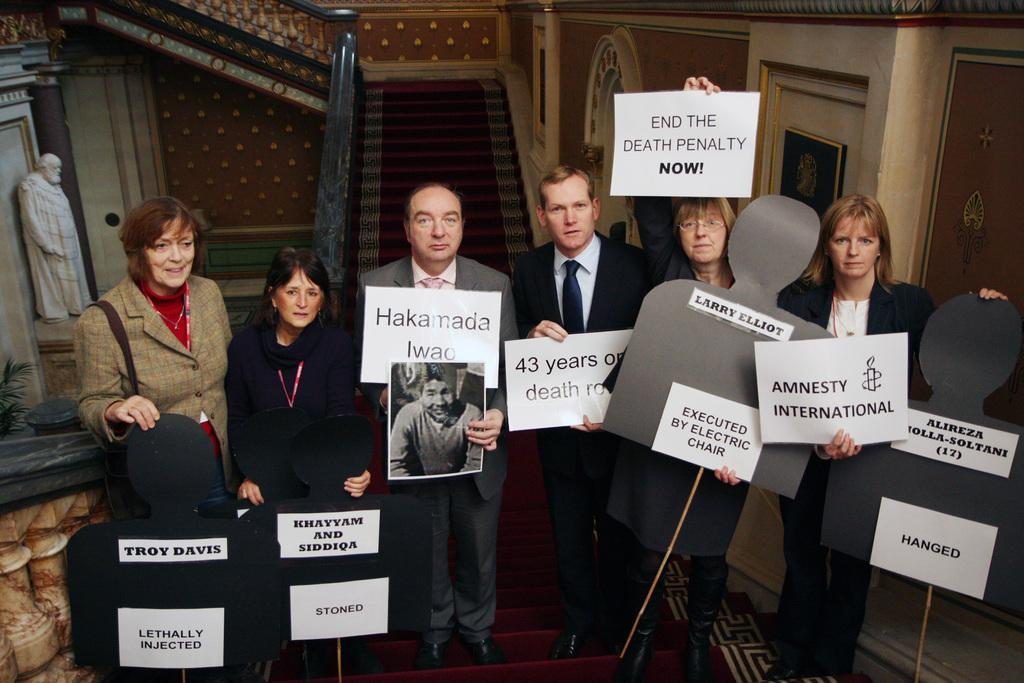How many people are in the image? There is a group of people in the image. What are the people holding in their hands? The people are holding papers and placards. What can be seen in the background of the image? There is a plant and a statue in the background of the image. Is there any decoration on the wall in the image? Yes, there is a frame on the wall in the image. What flavor of mask is being worn by the people in the image? There are no masks present in the image, and therefore no flavor can be determined. 